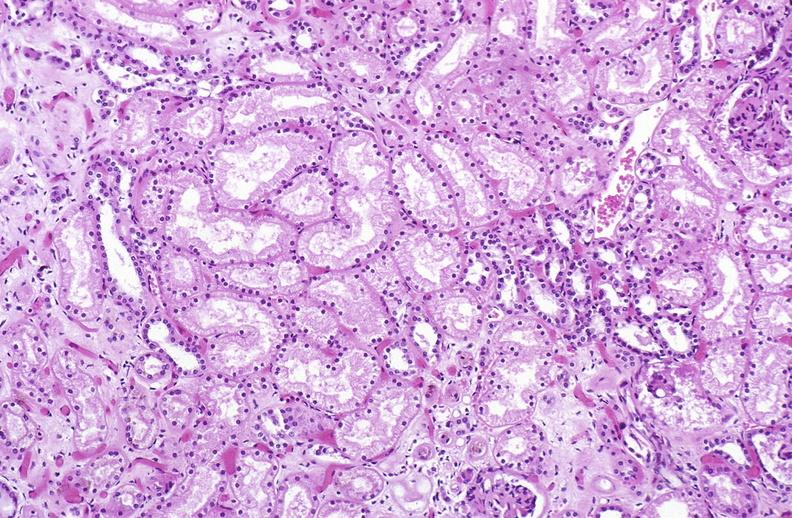what does this image show?
Answer the question using a single word or phrase. Atn acute tubular necrosis 